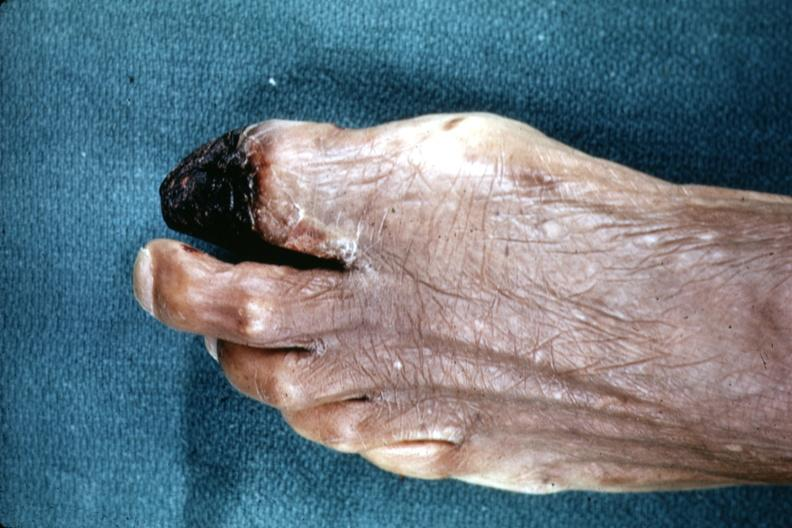does side show excellent example of gangrene of great toe?
Answer the question using a single word or phrase. No 